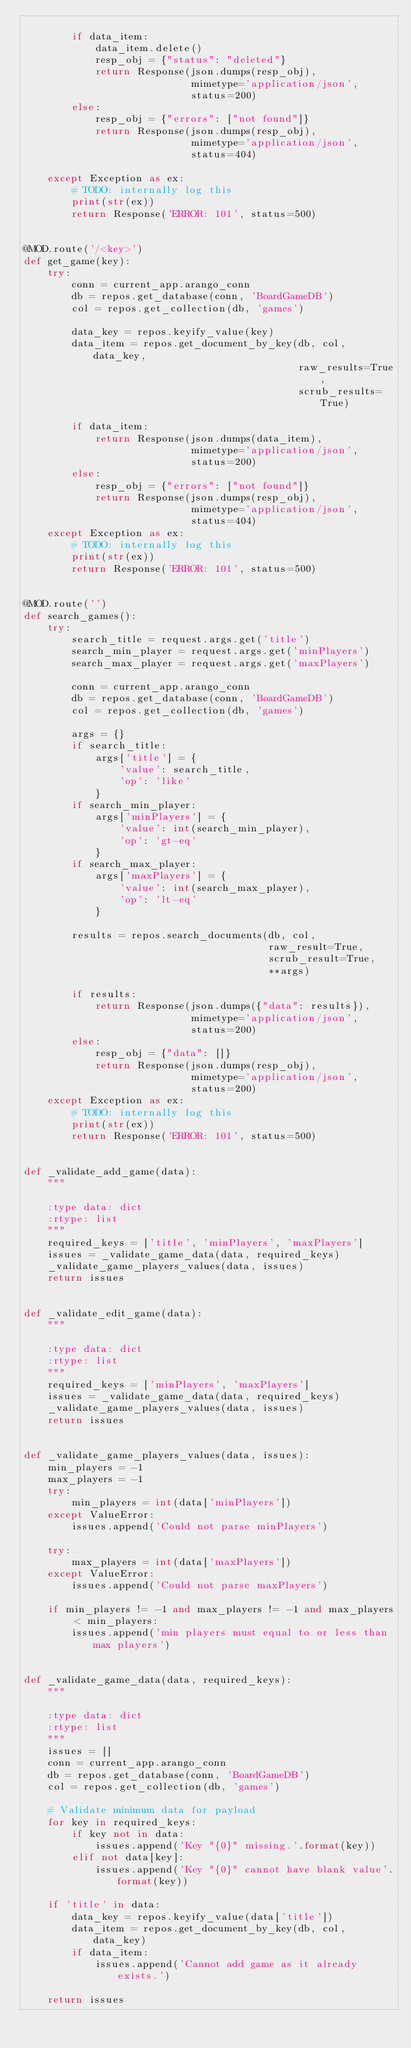Convert code to text. <code><loc_0><loc_0><loc_500><loc_500><_Python_>
        if data_item:
            data_item.delete()
            resp_obj = {"status": "deleted"}
            return Response(json.dumps(resp_obj),
                            mimetype='application/json',
                            status=200)
        else:
            resp_obj = {"errors": ["not found"]}
            return Response(json.dumps(resp_obj),
                            mimetype='application/json',
                            status=404)

    except Exception as ex:
        # TODO: internally log this
        print(str(ex))
        return Response('ERROR: 101', status=500)


@MOD.route('/<key>')
def get_game(key):
    try:
        conn = current_app.arango_conn
        db = repos.get_database(conn, 'BoardGameDB')
        col = repos.get_collection(db, 'games')

        data_key = repos.keyify_value(key)
        data_item = repos.get_document_by_key(db, col, data_key,
                                              raw_results=True,
                                              scrub_results=True)

        if data_item:
            return Response(json.dumps(data_item),
                            mimetype='application/json',
                            status=200)
        else:
            resp_obj = {"errors": ["not found"]}
            return Response(json.dumps(resp_obj),
                            mimetype='application/json',
                            status=404)
    except Exception as ex:
        # TODO: internally log this
        print(str(ex))
        return Response('ERROR: 101', status=500)


@MOD.route('')
def search_games():
    try:
        search_title = request.args.get('title')
        search_min_player = request.args.get('minPlayers')
        search_max_player = request.args.get('maxPlayers')

        conn = current_app.arango_conn
        db = repos.get_database(conn, 'BoardGameDB')
        col = repos.get_collection(db, 'games')

        args = {}
        if search_title:
            args['title'] = {
                'value': search_title,
                'op': 'like'
            }
        if search_min_player:
            args['minPlayers'] = {
                'value': int(search_min_player),
                'op': 'gt-eq'
            }
        if search_max_player:
            args['maxPlayers'] = {
                'value': int(search_max_player),
                'op': 'lt-eq'
            }

        results = repos.search_documents(db, col,
                                         raw_result=True,
                                         scrub_result=True,
                                         **args)

        if results:
            return Response(json.dumps({"data": results}),
                            mimetype='application/json',
                            status=200)
        else:
            resp_obj = {"data": []}
            return Response(json.dumps(resp_obj),
                            mimetype='application/json',
                            status=200)
    except Exception as ex:
        # TODO: internally log this
        print(str(ex))
        return Response('ERROR: 101', status=500)


def _validate_add_game(data):
    """

    :type data: dict
    :rtype: list
    """
    required_keys = ['title', 'minPlayers', 'maxPlayers']
    issues = _validate_game_data(data, required_keys)
    _validate_game_players_values(data, issues)
    return issues


def _validate_edit_game(data):
    """

    :type data: dict
    :rtype: list
    """
    required_keys = ['minPlayers', 'maxPlayers']
    issues = _validate_game_data(data, required_keys)
    _validate_game_players_values(data, issues)
    return issues


def _validate_game_players_values(data, issues):
    min_players = -1
    max_players = -1
    try:
        min_players = int(data['minPlayers'])
    except ValueError:
        issues.append('Could not parse minPlayers')

    try:
        max_players = int(data['maxPlayers'])
    except ValueError:
        issues.append('Could not parse maxPlayers')

    if min_players != -1 and max_players != -1 and max_players < min_players:
        issues.append('min players must equal to or less than max players')


def _validate_game_data(data, required_keys):
    """

    :type data: dict
    :rtype: list
    """
    issues = []
    conn = current_app.arango_conn
    db = repos.get_database(conn, 'BoardGameDB')
    col = repos.get_collection(db, 'games')

    # Validate minimum data for payload
    for key in required_keys:
        if key not in data:
            issues.append('Key "{0}" missing.'.format(key))
        elif not data[key]:
            issues.append('Key "{0}" cannot have blank value'.format(key))

    if 'title' in data:
        data_key = repos.keyify_value(data['title'])
        data_item = repos.get_document_by_key(db, col, data_key)
        if data_item:
            issues.append('Cannot add game as it already exists.')

    return issues
</code> 